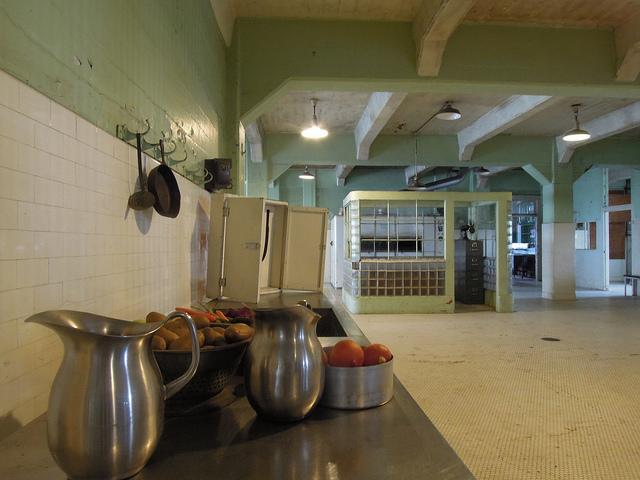Which food provides the most vitamin A? carrots 